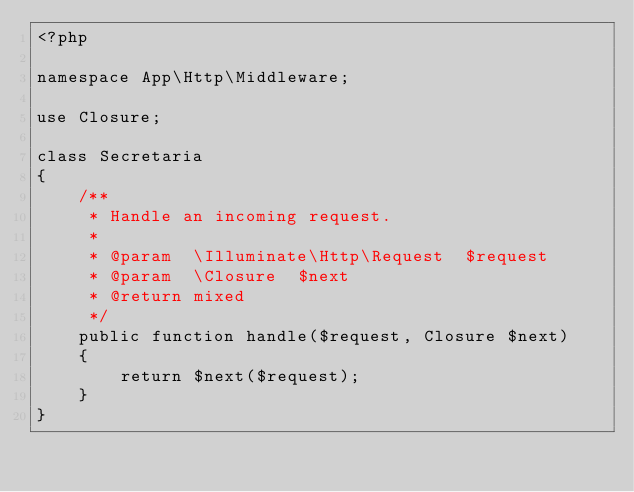Convert code to text. <code><loc_0><loc_0><loc_500><loc_500><_PHP_><?php

namespace App\Http\Middleware;

use Closure;

class Secretaria
{
    /**
     * Handle an incoming request.
     *
     * @param  \Illuminate\Http\Request  $request
     * @param  \Closure  $next
     * @return mixed
     */
    public function handle($request, Closure $next)
    {
        return $next($request);
    }
}
</code> 